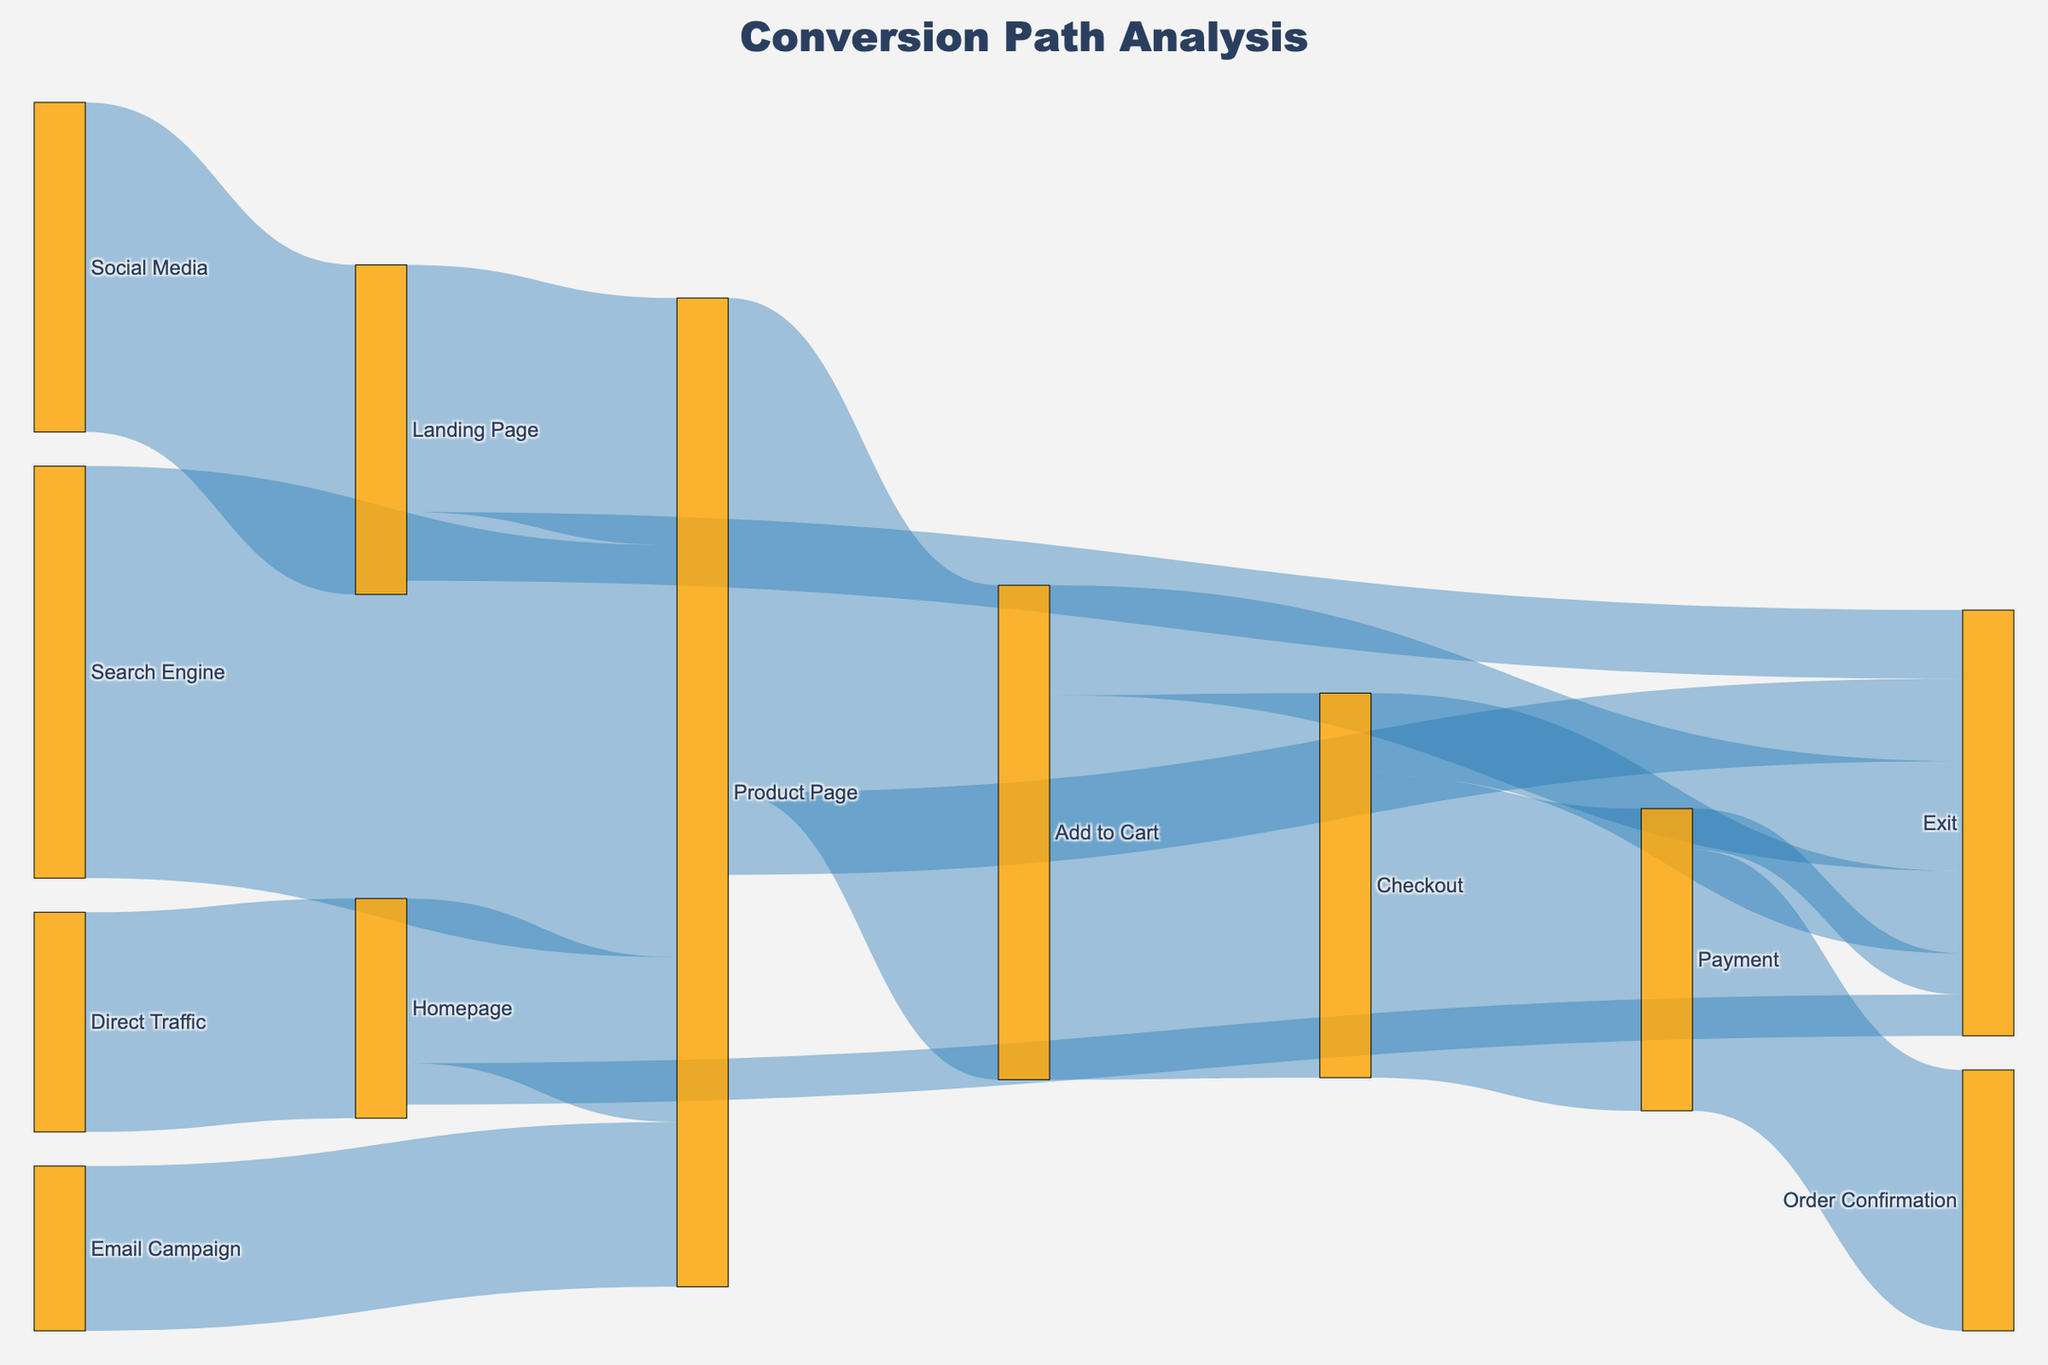What is the title of the figure? The title of the figure is located at the top and centered. By visual inspection, it can be read directly.
Answer: Conversion Path Analysis What are the two sources leading to the highest initial interactions? The highest initial interactions can be identified by the thickness of the arrows at the start of the paths.  The "Product Page" has the highest interactions with incoming paths "Search Engine" with 1500 and "Landing Page" with 900.
Answer: Search Engine, Landing Page Which interaction step has the highest number of exits? By observing the exit paths (labelled "Exit"), we compare their values. The step "Add to Cart" shows the highest exits with a value of 400.
Answer: Add to Cart How many people exited from the "Checkout" step? Look for the arrow labeled "Checkout" leading to "Exit" and check the value. The number shown is 300.
Answer: 300 Which path has the highest conversion from start to end without exiting? Trace the path with the most significant flow from a starting source all the way to "Order Confirmation" without exiting. The path "Search Engine -> Product Page -> Add to Cart -> Checkout -> Payment -> Order Confirmation" has the highest values.
Answer: Search Engine -> Product Page -> Add to Cart -> Checkout -> Payment -> Order Confirmation What is the total number of people that reached the "Product Page"? Sum the values of all paths leading into the "Product Page". These are "Search Engine" (1500), "Landing Page" (900), "Homepage" (600), and "Email Campaign" (600). 1500 + 900 + 600 + 600 = 3600.
Answer: 3600 Compare the number of people moving from "Product Page" to "Add to Cart" versus those who exit from "Product Page". Which is higher? Examine the arrows coming out of "Product Page": to "Add to Cart" is 1800 and to "Exit" is 300. Compare these values.
Answer: Add to Cart What percentage of people who added items to the cart proceeded to checkout? The number of people moving from "Add to Cart" to "Checkout" is 1400. The total number of people adding items to the cart is 1800. The percentage is (1400/1800) * 100 = 77.78%.
Answer: 77.78% How many people ultimately confirmed their orders after the payment step? The number of people moving from "Payment" to "Order Confirmation" is 950. This value is given directly by observing the arrow between "Payment" and "Order Confirmation".
Answer: 950 